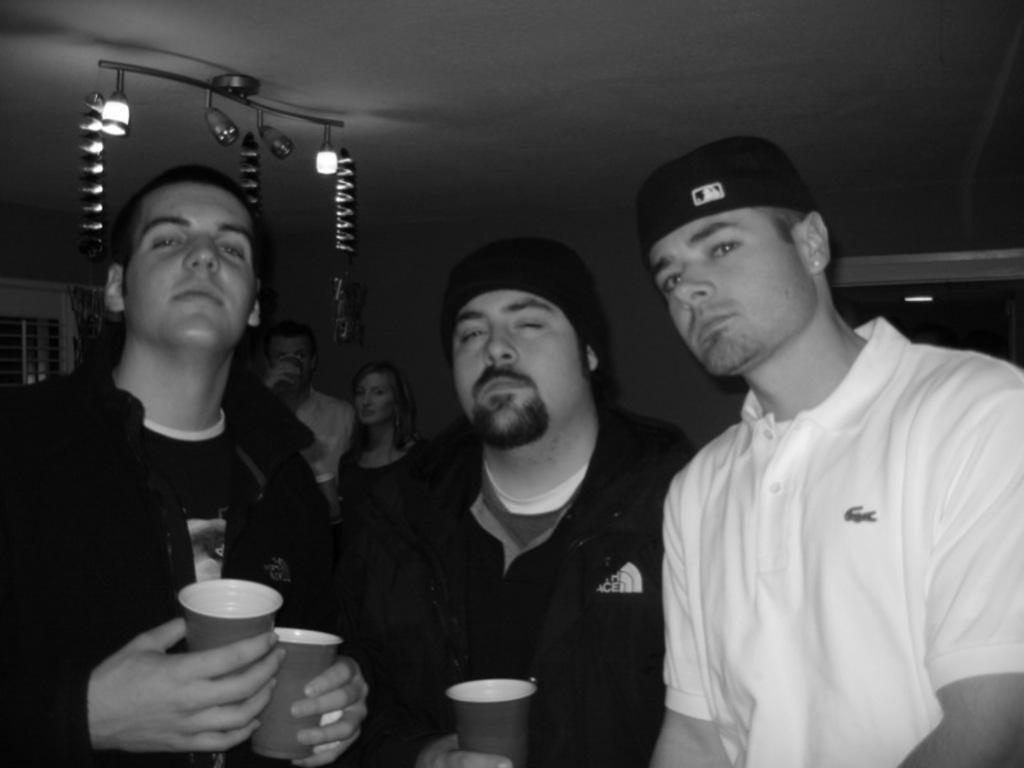Please provide a concise description of this image. This is a black and white picture. In this image, we can see people. Few people are holding glasses. In the background, we can see wall, ceiling, lights, windows, curtains and showpieces. 